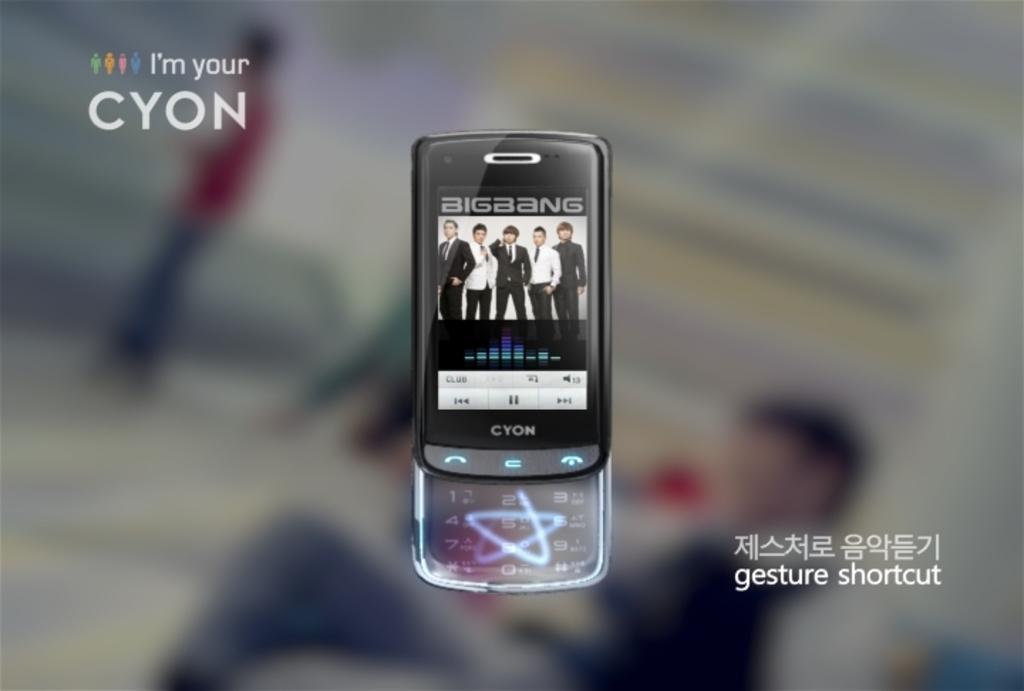Describe this image in one or two sentences. This is an edited image. In this image, in the middle, we can see a mobile, in the mobile, we can see some pictures and a keyboard. On the right side, we can see some text. 